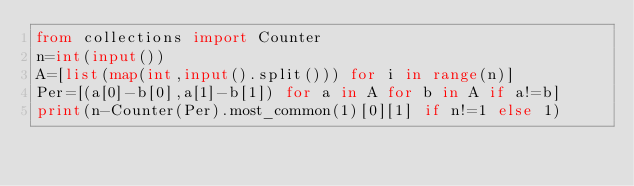<code> <loc_0><loc_0><loc_500><loc_500><_Python_>from collections import Counter
n=int(input())
A=[list(map(int,input().split())) for i in range(n)]
Per=[(a[0]-b[0],a[1]-b[1]) for a in A for b in A if a!=b]
print(n-Counter(Per).most_common(1)[0][1] if n!=1 else 1)</code> 